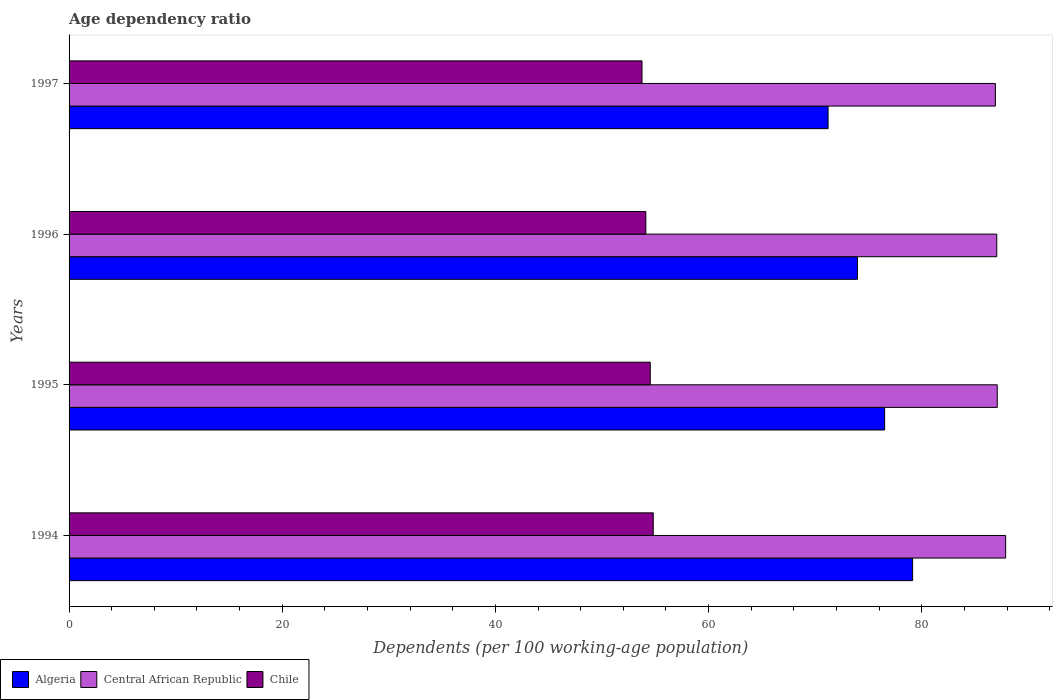How many different coloured bars are there?
Keep it short and to the point. 3. How many groups of bars are there?
Offer a terse response. 4. Are the number of bars per tick equal to the number of legend labels?
Provide a short and direct response. Yes. How many bars are there on the 4th tick from the bottom?
Provide a succinct answer. 3. What is the label of the 1st group of bars from the top?
Provide a short and direct response. 1997. In how many cases, is the number of bars for a given year not equal to the number of legend labels?
Provide a succinct answer. 0. What is the age dependency ratio in in Chile in 1994?
Ensure brevity in your answer.  54.81. Across all years, what is the maximum age dependency ratio in in Central African Republic?
Make the answer very short. 87.87. Across all years, what is the minimum age dependency ratio in in Central African Republic?
Keep it short and to the point. 86.91. In which year was the age dependency ratio in in Chile minimum?
Provide a short and direct response. 1997. What is the total age dependency ratio in in Chile in the graph?
Your answer should be very brief. 217.2. What is the difference between the age dependency ratio in in Algeria in 1994 and that in 1995?
Offer a terse response. 2.62. What is the difference between the age dependency ratio in in Central African Republic in 1994 and the age dependency ratio in in Algeria in 1997?
Offer a terse response. 16.66. What is the average age dependency ratio in in Central African Republic per year?
Your response must be concise. 87.22. In the year 1995, what is the difference between the age dependency ratio in in Chile and age dependency ratio in in Central African Republic?
Keep it short and to the point. -32.55. What is the ratio of the age dependency ratio in in Chile in 1994 to that in 1997?
Keep it short and to the point. 1.02. Is the age dependency ratio in in Algeria in 1994 less than that in 1996?
Make the answer very short. No. What is the difference between the highest and the second highest age dependency ratio in in Chile?
Provide a succinct answer. 0.28. What is the difference between the highest and the lowest age dependency ratio in in Central African Republic?
Your answer should be very brief. 0.96. Is the sum of the age dependency ratio in in Central African Republic in 1994 and 1996 greater than the maximum age dependency ratio in in Chile across all years?
Provide a short and direct response. Yes. What does the 2nd bar from the top in 1996 represents?
Make the answer very short. Central African Republic. What does the 2nd bar from the bottom in 1997 represents?
Ensure brevity in your answer.  Central African Republic. Is it the case that in every year, the sum of the age dependency ratio in in Algeria and age dependency ratio in in Central African Republic is greater than the age dependency ratio in in Chile?
Provide a short and direct response. Yes. Are all the bars in the graph horizontal?
Your response must be concise. Yes. What is the difference between two consecutive major ticks on the X-axis?
Your answer should be compact. 20. Does the graph contain any zero values?
Offer a very short reply. No. How many legend labels are there?
Your answer should be compact. 3. What is the title of the graph?
Provide a short and direct response. Age dependency ratio. What is the label or title of the X-axis?
Your answer should be compact. Dependents (per 100 working-age population). What is the Dependents (per 100 working-age population) of Algeria in 1994?
Provide a succinct answer. 79.14. What is the Dependents (per 100 working-age population) in Central African Republic in 1994?
Your answer should be compact. 87.87. What is the Dependents (per 100 working-age population) in Chile in 1994?
Provide a short and direct response. 54.81. What is the Dependents (per 100 working-age population) in Algeria in 1995?
Your response must be concise. 76.52. What is the Dependents (per 100 working-age population) in Central African Republic in 1995?
Provide a succinct answer. 87.08. What is the Dependents (per 100 working-age population) in Chile in 1995?
Provide a succinct answer. 54.53. What is the Dependents (per 100 working-age population) of Algeria in 1996?
Offer a very short reply. 73.96. What is the Dependents (per 100 working-age population) of Central African Republic in 1996?
Offer a terse response. 87.04. What is the Dependents (per 100 working-age population) in Chile in 1996?
Make the answer very short. 54.11. What is the Dependents (per 100 working-age population) in Algeria in 1997?
Your answer should be very brief. 71.21. What is the Dependents (per 100 working-age population) of Central African Republic in 1997?
Provide a succinct answer. 86.91. What is the Dependents (per 100 working-age population) in Chile in 1997?
Your response must be concise. 53.75. Across all years, what is the maximum Dependents (per 100 working-age population) in Algeria?
Keep it short and to the point. 79.14. Across all years, what is the maximum Dependents (per 100 working-age population) of Central African Republic?
Your response must be concise. 87.87. Across all years, what is the maximum Dependents (per 100 working-age population) of Chile?
Offer a terse response. 54.81. Across all years, what is the minimum Dependents (per 100 working-age population) of Algeria?
Your response must be concise. 71.21. Across all years, what is the minimum Dependents (per 100 working-age population) in Central African Republic?
Your answer should be compact. 86.91. Across all years, what is the minimum Dependents (per 100 working-age population) in Chile?
Make the answer very short. 53.75. What is the total Dependents (per 100 working-age population) in Algeria in the graph?
Your answer should be very brief. 300.83. What is the total Dependents (per 100 working-age population) of Central African Republic in the graph?
Offer a terse response. 348.89. What is the total Dependents (per 100 working-age population) in Chile in the graph?
Provide a succinct answer. 217.2. What is the difference between the Dependents (per 100 working-age population) in Algeria in 1994 and that in 1995?
Offer a very short reply. 2.62. What is the difference between the Dependents (per 100 working-age population) of Central African Republic in 1994 and that in 1995?
Ensure brevity in your answer.  0.79. What is the difference between the Dependents (per 100 working-age population) in Chile in 1994 and that in 1995?
Offer a terse response. 0.28. What is the difference between the Dependents (per 100 working-age population) of Algeria in 1994 and that in 1996?
Keep it short and to the point. 5.18. What is the difference between the Dependents (per 100 working-age population) in Central African Republic in 1994 and that in 1996?
Your answer should be compact. 0.83. What is the difference between the Dependents (per 100 working-age population) in Chile in 1994 and that in 1996?
Your answer should be very brief. 0.7. What is the difference between the Dependents (per 100 working-age population) of Algeria in 1994 and that in 1997?
Your answer should be very brief. 7.93. What is the difference between the Dependents (per 100 working-age population) of Central African Republic in 1994 and that in 1997?
Give a very brief answer. 0.96. What is the difference between the Dependents (per 100 working-age population) of Chile in 1994 and that in 1997?
Give a very brief answer. 1.05. What is the difference between the Dependents (per 100 working-age population) in Algeria in 1995 and that in 1996?
Make the answer very short. 2.55. What is the difference between the Dependents (per 100 working-age population) of Central African Republic in 1995 and that in 1996?
Offer a very short reply. 0.05. What is the difference between the Dependents (per 100 working-age population) of Chile in 1995 and that in 1996?
Provide a succinct answer. 0.42. What is the difference between the Dependents (per 100 working-age population) in Algeria in 1995 and that in 1997?
Give a very brief answer. 5.31. What is the difference between the Dependents (per 100 working-age population) of Central African Republic in 1995 and that in 1997?
Offer a very short reply. 0.17. What is the difference between the Dependents (per 100 working-age population) in Chile in 1995 and that in 1997?
Provide a short and direct response. 0.78. What is the difference between the Dependents (per 100 working-age population) in Algeria in 1996 and that in 1997?
Provide a succinct answer. 2.75. What is the difference between the Dependents (per 100 working-age population) in Central African Republic in 1996 and that in 1997?
Keep it short and to the point. 0.13. What is the difference between the Dependents (per 100 working-age population) of Chile in 1996 and that in 1997?
Your answer should be compact. 0.36. What is the difference between the Dependents (per 100 working-age population) in Algeria in 1994 and the Dependents (per 100 working-age population) in Central African Republic in 1995?
Provide a short and direct response. -7.94. What is the difference between the Dependents (per 100 working-age population) of Algeria in 1994 and the Dependents (per 100 working-age population) of Chile in 1995?
Provide a succinct answer. 24.61. What is the difference between the Dependents (per 100 working-age population) of Central African Republic in 1994 and the Dependents (per 100 working-age population) of Chile in 1995?
Provide a short and direct response. 33.34. What is the difference between the Dependents (per 100 working-age population) of Algeria in 1994 and the Dependents (per 100 working-age population) of Central African Republic in 1996?
Your answer should be compact. -7.89. What is the difference between the Dependents (per 100 working-age population) in Algeria in 1994 and the Dependents (per 100 working-age population) in Chile in 1996?
Give a very brief answer. 25.03. What is the difference between the Dependents (per 100 working-age population) of Central African Republic in 1994 and the Dependents (per 100 working-age population) of Chile in 1996?
Provide a succinct answer. 33.76. What is the difference between the Dependents (per 100 working-age population) in Algeria in 1994 and the Dependents (per 100 working-age population) in Central African Republic in 1997?
Provide a succinct answer. -7.77. What is the difference between the Dependents (per 100 working-age population) in Algeria in 1994 and the Dependents (per 100 working-age population) in Chile in 1997?
Offer a very short reply. 25.39. What is the difference between the Dependents (per 100 working-age population) of Central African Republic in 1994 and the Dependents (per 100 working-age population) of Chile in 1997?
Make the answer very short. 34.12. What is the difference between the Dependents (per 100 working-age population) of Algeria in 1995 and the Dependents (per 100 working-age population) of Central African Republic in 1996?
Your answer should be compact. -10.52. What is the difference between the Dependents (per 100 working-age population) of Algeria in 1995 and the Dependents (per 100 working-age population) of Chile in 1996?
Provide a succinct answer. 22.41. What is the difference between the Dependents (per 100 working-age population) in Central African Republic in 1995 and the Dependents (per 100 working-age population) in Chile in 1996?
Ensure brevity in your answer.  32.97. What is the difference between the Dependents (per 100 working-age population) in Algeria in 1995 and the Dependents (per 100 working-age population) in Central African Republic in 1997?
Keep it short and to the point. -10.39. What is the difference between the Dependents (per 100 working-age population) of Algeria in 1995 and the Dependents (per 100 working-age population) of Chile in 1997?
Provide a short and direct response. 22.77. What is the difference between the Dependents (per 100 working-age population) in Central African Republic in 1995 and the Dependents (per 100 working-age population) in Chile in 1997?
Give a very brief answer. 33.33. What is the difference between the Dependents (per 100 working-age population) in Algeria in 1996 and the Dependents (per 100 working-age population) in Central African Republic in 1997?
Offer a terse response. -12.94. What is the difference between the Dependents (per 100 working-age population) in Algeria in 1996 and the Dependents (per 100 working-age population) in Chile in 1997?
Give a very brief answer. 20.21. What is the difference between the Dependents (per 100 working-age population) of Central African Republic in 1996 and the Dependents (per 100 working-age population) of Chile in 1997?
Give a very brief answer. 33.28. What is the average Dependents (per 100 working-age population) of Algeria per year?
Your response must be concise. 75.21. What is the average Dependents (per 100 working-age population) of Central African Republic per year?
Your answer should be very brief. 87.22. What is the average Dependents (per 100 working-age population) in Chile per year?
Offer a very short reply. 54.3. In the year 1994, what is the difference between the Dependents (per 100 working-age population) in Algeria and Dependents (per 100 working-age population) in Central African Republic?
Give a very brief answer. -8.73. In the year 1994, what is the difference between the Dependents (per 100 working-age population) of Algeria and Dependents (per 100 working-age population) of Chile?
Your answer should be compact. 24.33. In the year 1994, what is the difference between the Dependents (per 100 working-age population) in Central African Republic and Dependents (per 100 working-age population) in Chile?
Provide a short and direct response. 33.06. In the year 1995, what is the difference between the Dependents (per 100 working-age population) in Algeria and Dependents (per 100 working-age population) in Central African Republic?
Ensure brevity in your answer.  -10.56. In the year 1995, what is the difference between the Dependents (per 100 working-age population) of Algeria and Dependents (per 100 working-age population) of Chile?
Make the answer very short. 21.99. In the year 1995, what is the difference between the Dependents (per 100 working-age population) in Central African Republic and Dependents (per 100 working-age population) in Chile?
Offer a very short reply. 32.55. In the year 1996, what is the difference between the Dependents (per 100 working-age population) in Algeria and Dependents (per 100 working-age population) in Central African Republic?
Keep it short and to the point. -13.07. In the year 1996, what is the difference between the Dependents (per 100 working-age population) in Algeria and Dependents (per 100 working-age population) in Chile?
Provide a short and direct response. 19.85. In the year 1996, what is the difference between the Dependents (per 100 working-age population) of Central African Republic and Dependents (per 100 working-age population) of Chile?
Provide a short and direct response. 32.92. In the year 1997, what is the difference between the Dependents (per 100 working-age population) in Algeria and Dependents (per 100 working-age population) in Central African Republic?
Your answer should be compact. -15.7. In the year 1997, what is the difference between the Dependents (per 100 working-age population) in Algeria and Dependents (per 100 working-age population) in Chile?
Give a very brief answer. 17.46. In the year 1997, what is the difference between the Dependents (per 100 working-age population) of Central African Republic and Dependents (per 100 working-age population) of Chile?
Make the answer very short. 33.15. What is the ratio of the Dependents (per 100 working-age population) of Algeria in 1994 to that in 1995?
Offer a very short reply. 1.03. What is the ratio of the Dependents (per 100 working-age population) in Central African Republic in 1994 to that in 1995?
Ensure brevity in your answer.  1.01. What is the ratio of the Dependents (per 100 working-age population) of Chile in 1994 to that in 1995?
Offer a very short reply. 1.01. What is the ratio of the Dependents (per 100 working-age population) of Algeria in 1994 to that in 1996?
Make the answer very short. 1.07. What is the ratio of the Dependents (per 100 working-age population) of Central African Republic in 1994 to that in 1996?
Make the answer very short. 1.01. What is the ratio of the Dependents (per 100 working-age population) in Chile in 1994 to that in 1996?
Your answer should be very brief. 1.01. What is the ratio of the Dependents (per 100 working-age population) in Algeria in 1994 to that in 1997?
Your response must be concise. 1.11. What is the ratio of the Dependents (per 100 working-age population) in Central African Republic in 1994 to that in 1997?
Offer a terse response. 1.01. What is the ratio of the Dependents (per 100 working-age population) in Chile in 1994 to that in 1997?
Offer a very short reply. 1.02. What is the ratio of the Dependents (per 100 working-age population) of Algeria in 1995 to that in 1996?
Your answer should be very brief. 1.03. What is the ratio of the Dependents (per 100 working-age population) of Chile in 1995 to that in 1996?
Your answer should be very brief. 1.01. What is the ratio of the Dependents (per 100 working-age population) in Algeria in 1995 to that in 1997?
Keep it short and to the point. 1.07. What is the ratio of the Dependents (per 100 working-age population) in Central African Republic in 1995 to that in 1997?
Keep it short and to the point. 1. What is the ratio of the Dependents (per 100 working-age population) of Chile in 1995 to that in 1997?
Your response must be concise. 1.01. What is the ratio of the Dependents (per 100 working-age population) in Algeria in 1996 to that in 1997?
Provide a short and direct response. 1.04. What is the difference between the highest and the second highest Dependents (per 100 working-age population) of Algeria?
Provide a short and direct response. 2.62. What is the difference between the highest and the second highest Dependents (per 100 working-age population) of Central African Republic?
Provide a short and direct response. 0.79. What is the difference between the highest and the second highest Dependents (per 100 working-age population) of Chile?
Provide a succinct answer. 0.28. What is the difference between the highest and the lowest Dependents (per 100 working-age population) of Algeria?
Your response must be concise. 7.93. What is the difference between the highest and the lowest Dependents (per 100 working-age population) in Central African Republic?
Make the answer very short. 0.96. What is the difference between the highest and the lowest Dependents (per 100 working-age population) in Chile?
Give a very brief answer. 1.05. 